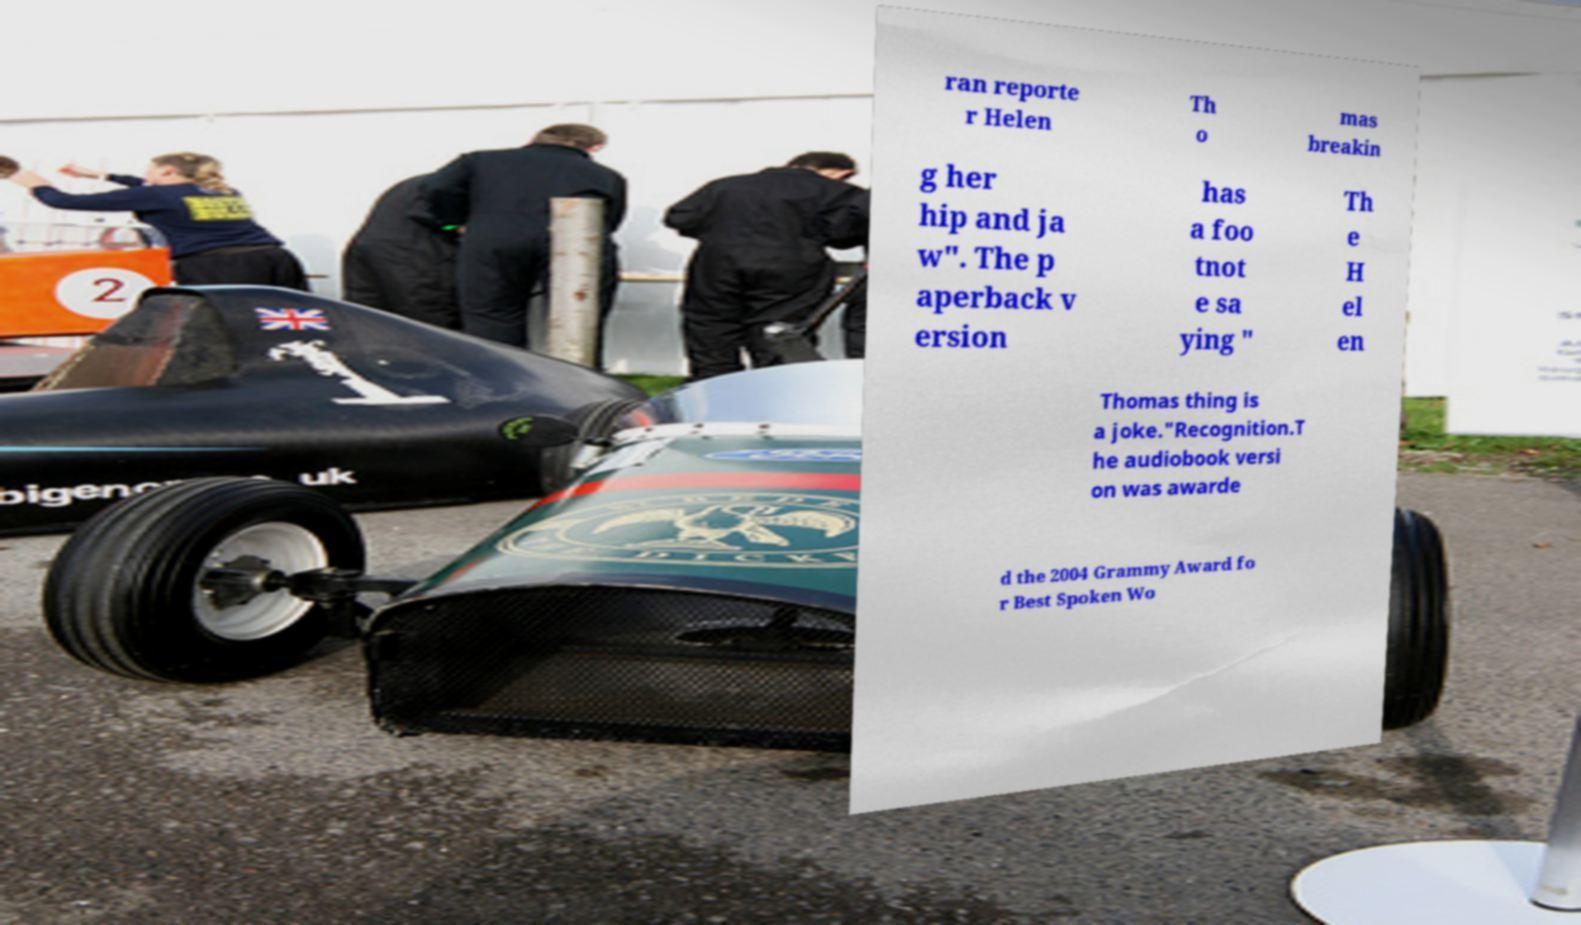Could you extract and type out the text from this image? ran reporte r Helen Th o mas breakin g her hip and ja w". The p aperback v ersion has a foo tnot e sa ying " Th e H el en Thomas thing is a joke."Recognition.T he audiobook versi on was awarde d the 2004 Grammy Award fo r Best Spoken Wo 